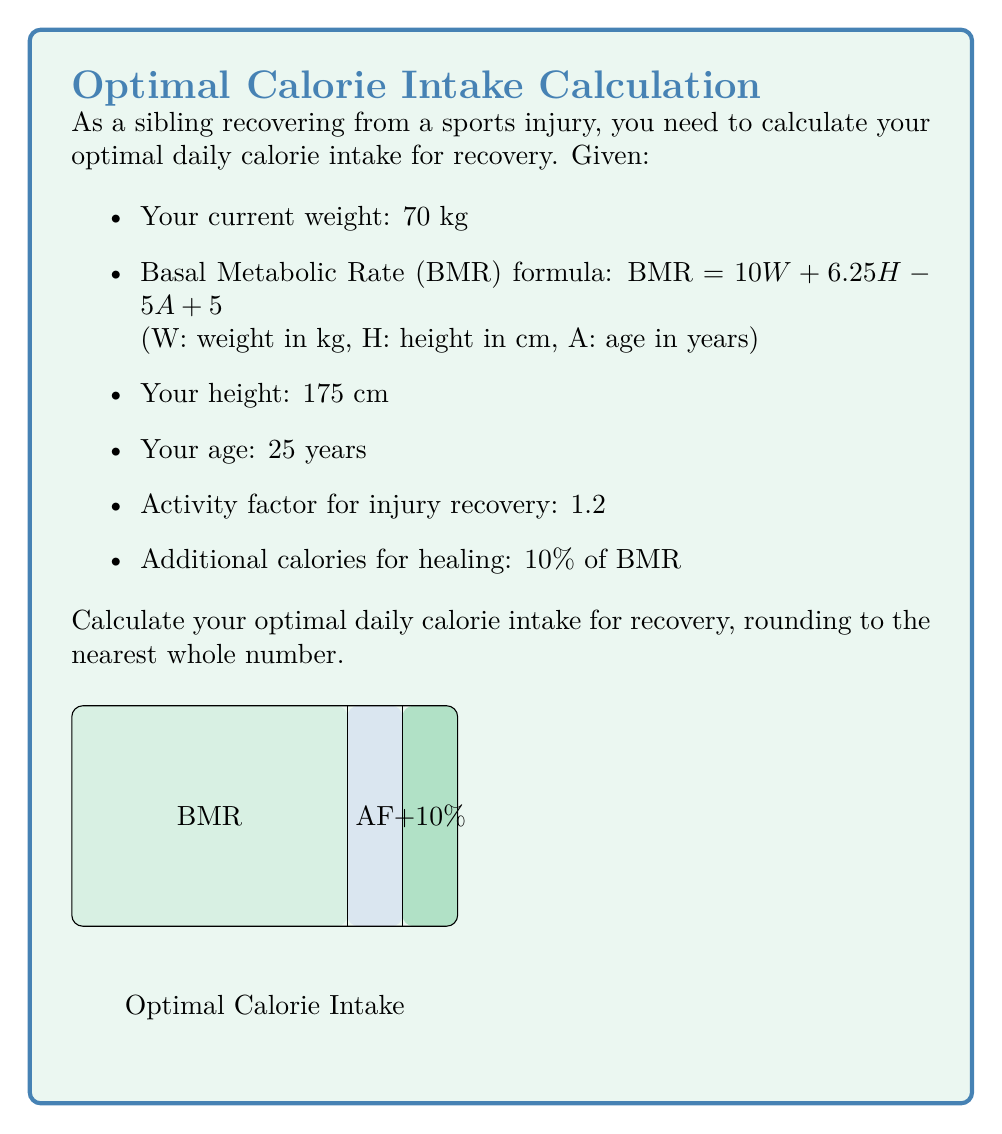Help me with this question. Let's break this down step-by-step:

1) First, calculate the BMR using the given formula:
   $BMR = 10W + 6.25H - 5A + 5$
   $BMR = 10(70) + 6.25(175) - 5(25) + 5$
   $BMR = 700 + 1093.75 - 125 + 5$
   $BMR = 1673.75$ calories

2) Apply the activity factor for injury recovery:
   $Calories_{activity} = BMR \times 1.2$
   $Calories_{activity} = 1673.75 \times 1.2 = 2008.5$ calories

3) Calculate the additional calories for healing (10% of BMR):
   $Calories_{healing} = BMR \times 0.1$
   $Calories_{healing} = 1673.75 \times 0.1 = 167.375$ calories

4) Sum up the total calories:
   $Total_{calories} = Calories_{activity} + Calories_{healing}$
   $Total_{calories} = 2008.5 + 167.375 = 2175.875$ calories

5) Round to the nearest whole number:
   $Optimal_{calories} = round(2175.875) = 2176$ calories

Therefore, the optimal daily calorie intake for recovery is 2176 calories.
Answer: 2176 calories 